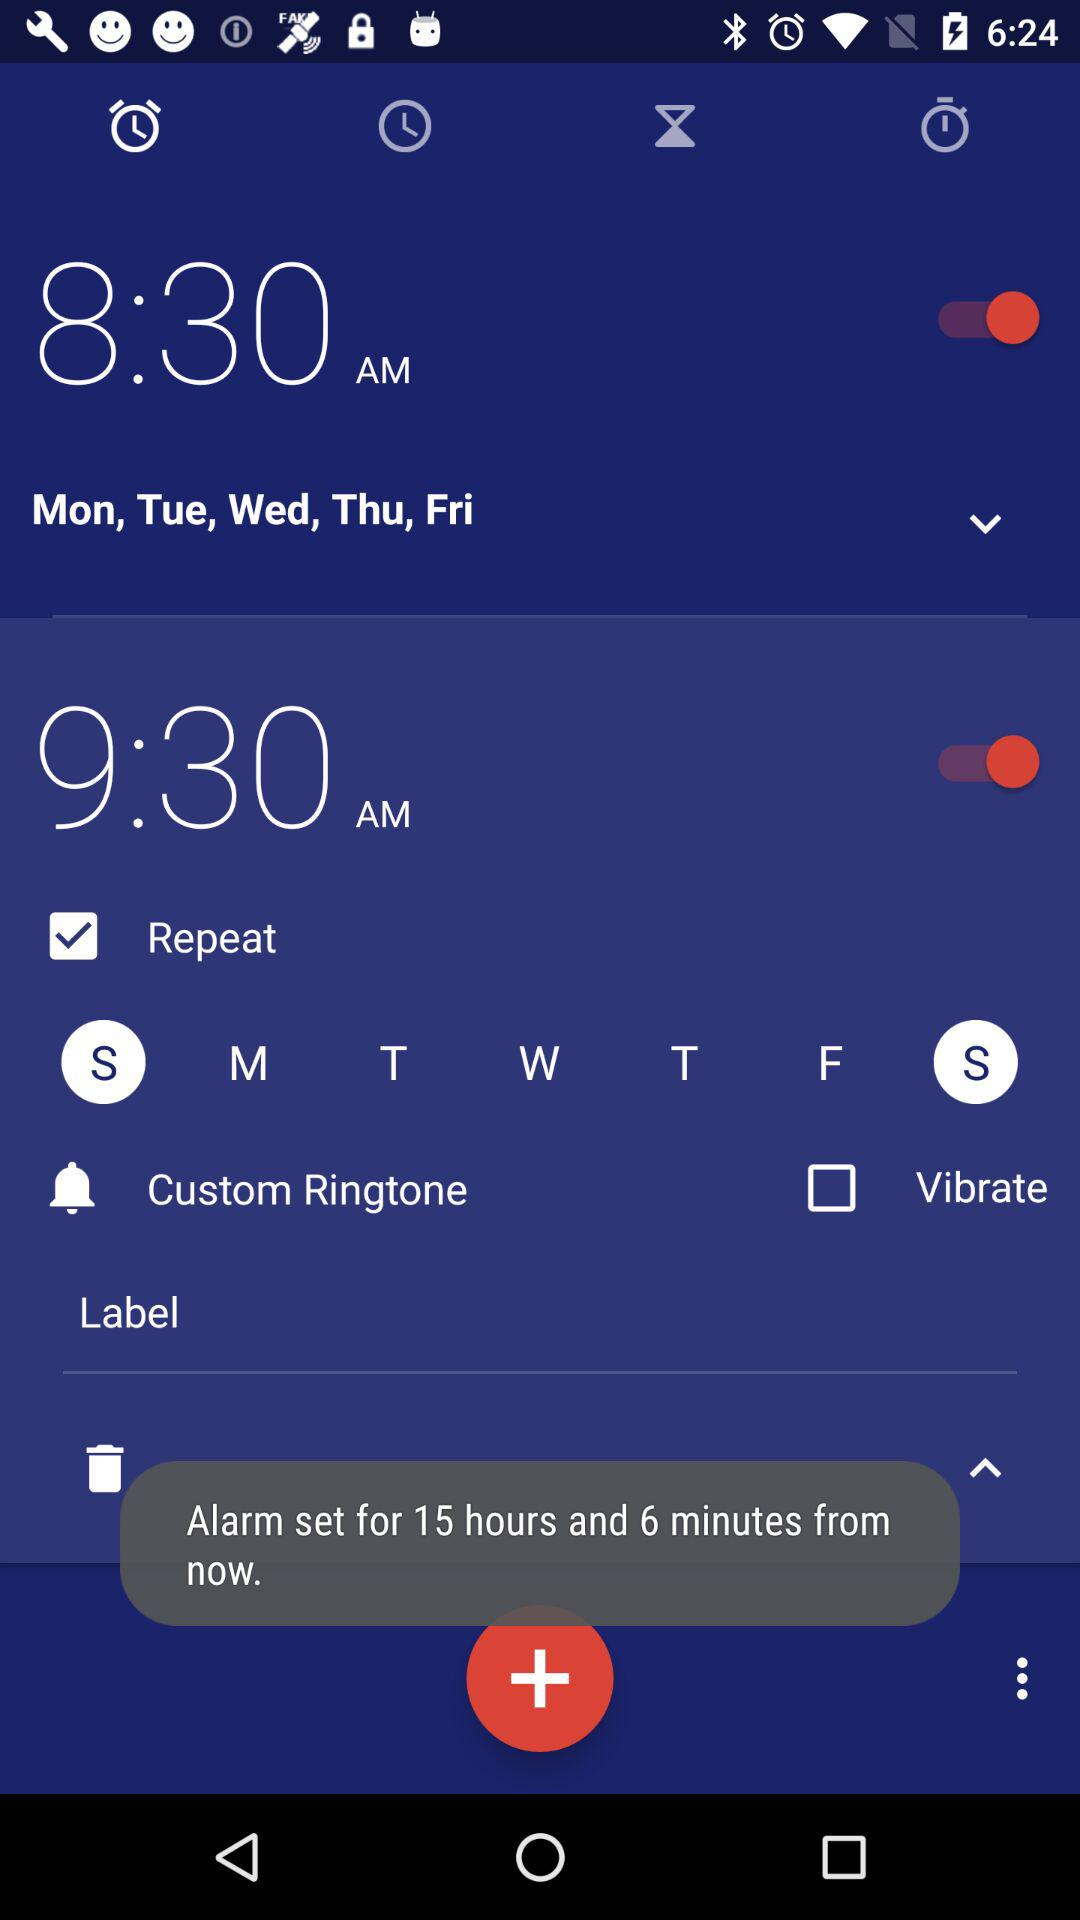What is the selected alarm time for Sunday? The selected alarm time is 9:30 AM. 